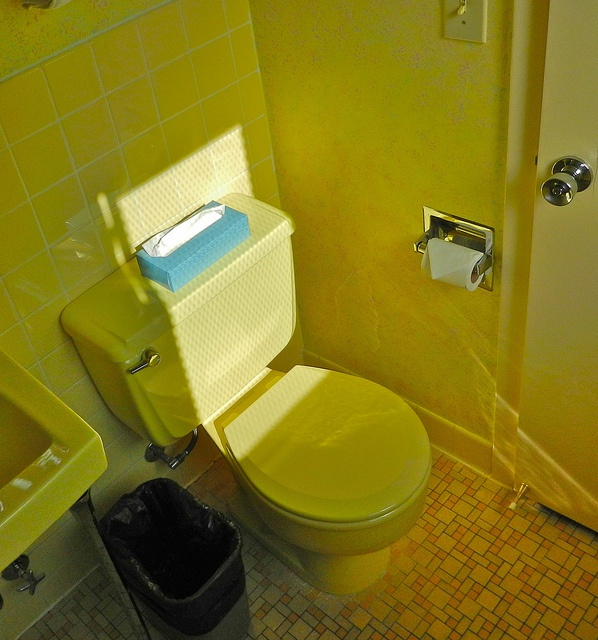Describe the objects in this image and their specific colors. I can see toilet in olive and khaki tones and sink in olive tones in this image. 